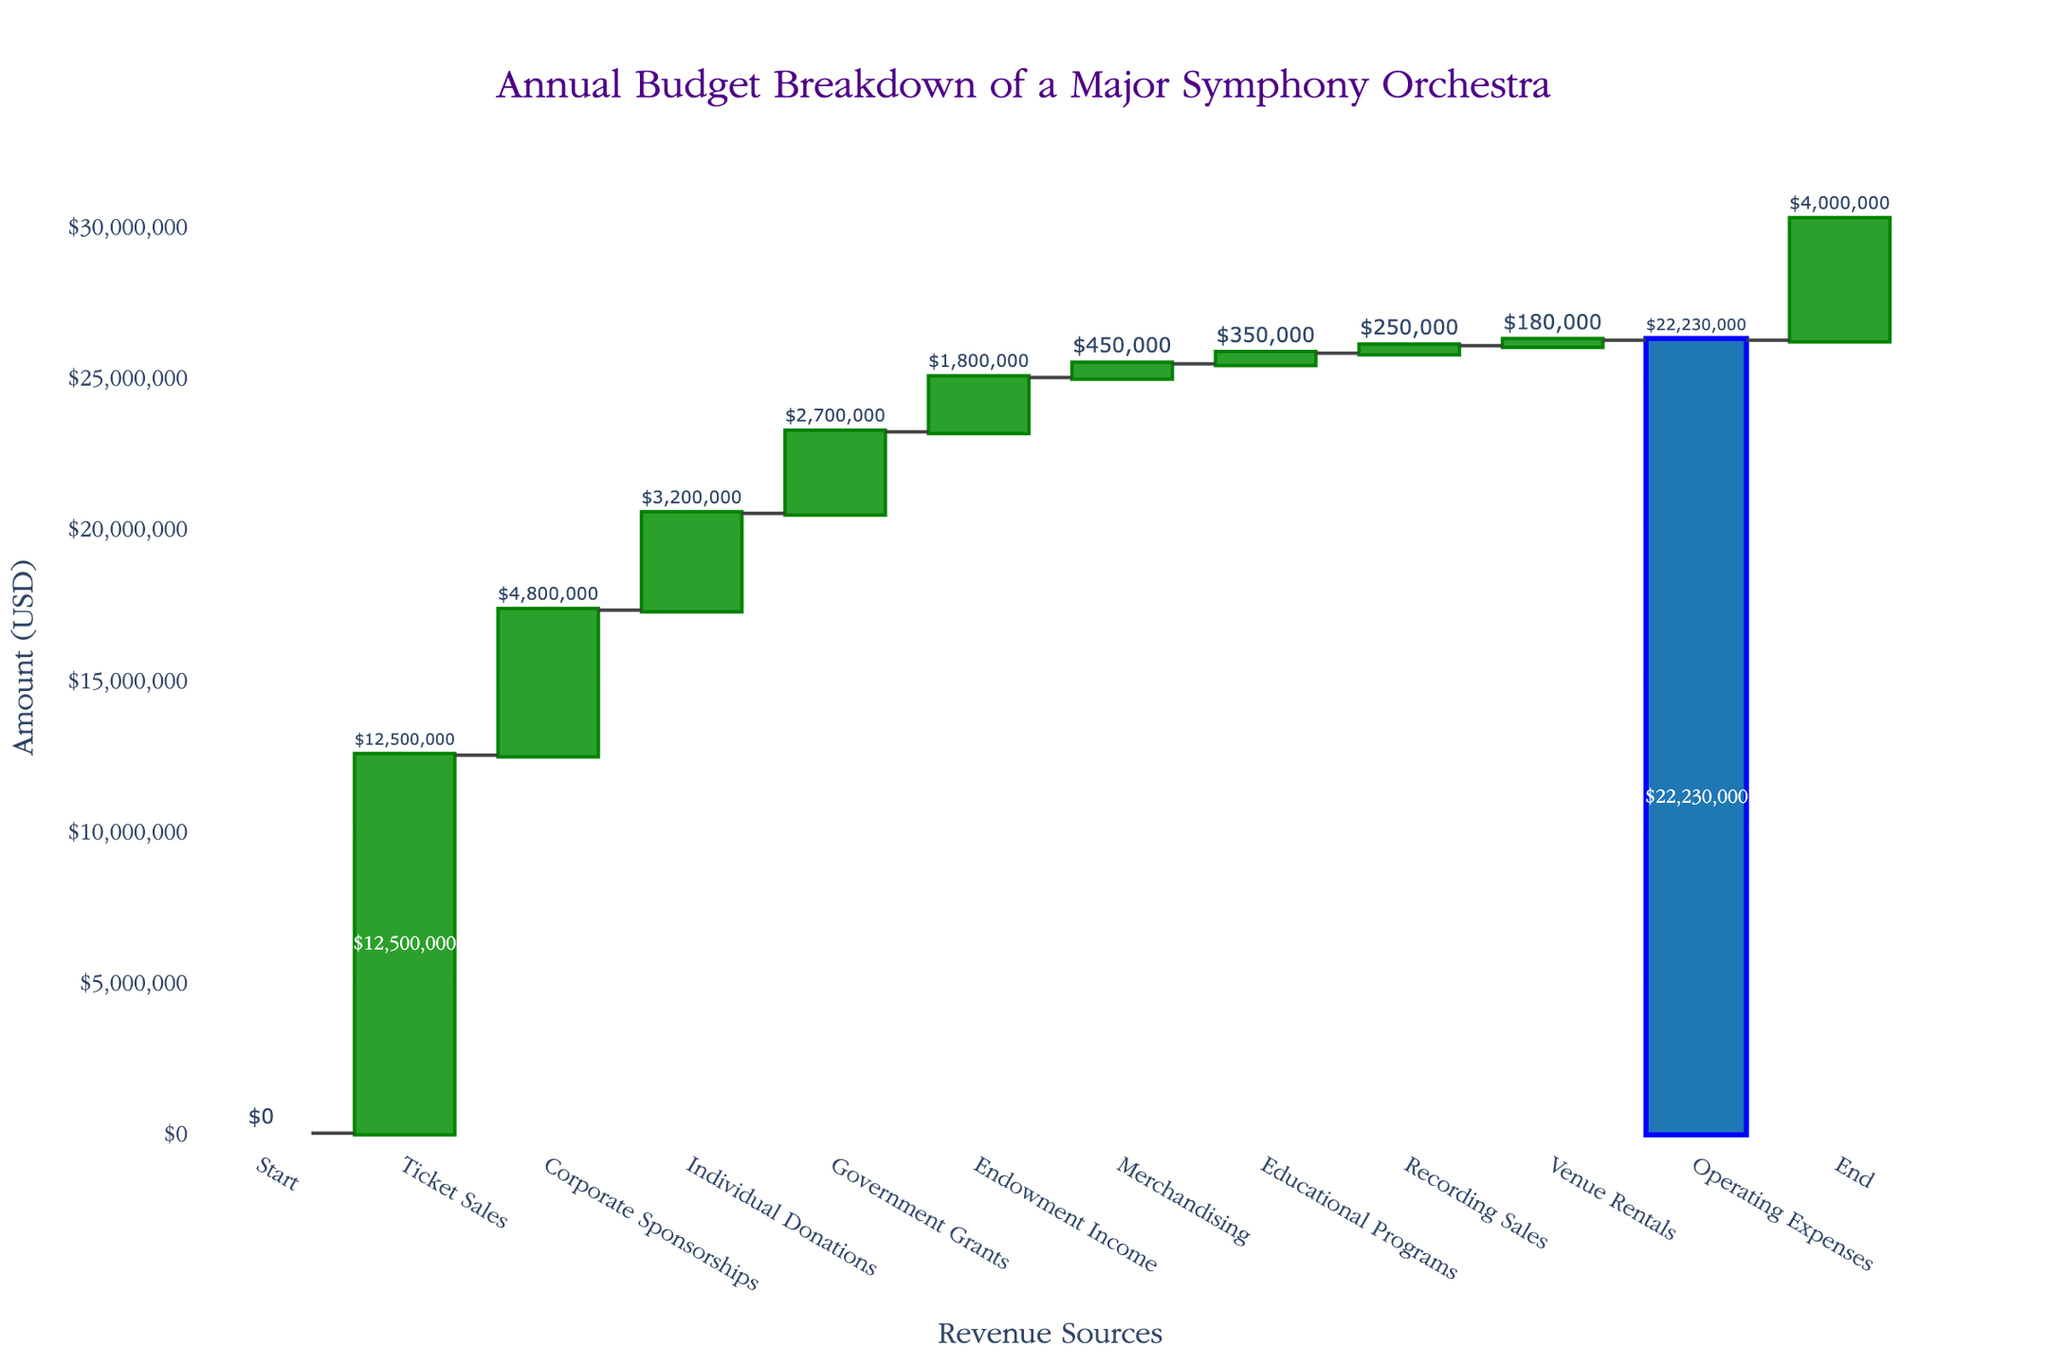what is the title of the chart? The title is displayed prominently at the top of the chart and reads, "Annual Budget Breakdown of a Major Symphony Orchestra".
Answer: Annual Budget Breakdown of a Major Symphony Orchestra How many categories are shown in the waterfall chart? By counting the individual bars on the x-axis of the chart, we can see the categories: Start, Ticket Sales, Corporate Sponsorships, Individual Donations, Government Grants, Endowment Income, Merchandising, Educational Programs, Recording Sales, Venue Rentals, Operating Expenses, and End. This sums up to 12 categories.
Answer: 12 What is the color used to indicate increasing values? The bars that represent increasing values are colored green, which indicates positive contributions to the revenue.
Answer: Green What is the total revenue from "Ticket Sales," "Corporate Sponsorships," and "Individual Donations"? Add the values for Ticket Sales ($12,500,000), Corporate Sponsorships ($4,800,000), and Individual Donations ($3,200,000). $12,500,000 + $4,800,000 + $3,200,000 = $20,500,000.
Answer: $20,500,000 What is the overall surplus or deficit before considering the 'End' category? Sum all the amounts excluding the 'Start' and 'End' categories: $0 + $12,500,000 + $4,800,000 + $3,200,000 + $2,700,000 + $1,800,000 + $450,000 + $350,000 + $250,000 + $180,000 - $22,230,000. This equals -$3,000,000.
Answer: -$3,000,000 Which revenue source contributes the least to the total revenue? By comparing the amounts visually and numerically, "Recording Sales" adds the least amount, which is $250,000.
Answer: Recording Sales How much more revenue does "Ticket Sales" generate compared to "Government Grants"? Subtract the amount for Government Grants ($2,700,000) from Ticket Sales ($12,500,000). $12,500,000 - $2,700,000 = $9,800,000.
Answer: $9,800,000 What is the total amount of revenue generated by all the revenue sources combined (excluding expenses and 'End')? Sum the values of Ticket Sales ($12,500,000), Corporate Sponsorships ($4,800,000), Individual Donations ($3,200,000), Government Grants ($2,700,000), Endowment Income ($1,800,000), Merchandising ($450,000), Educational Programs ($350,000), Recording Sales ($250,000), and Venue Rentals ($180,000). This results in $26,230,000.
Answer: $26,230,000 Explain how the "End" value is derived based on the chart. The "End" value represents the total surplus or deficit after incorporating all revenue sources and expenses. Starting from $0, add all positive values (totaling $26,230,000) and then subtract the operating expenses ($22,230,000). $26,230,000 - $22,230,000 equals $4,000,000 which is shown as "End".
Answer: $4,000,000 How does the sum of "Endowment Income" and "Merchandising" compare to "Operating Expenses"? First, find the sum of Endowment Income and Merchandising: $1,800,000 + $450,000 = $2,250,000. Next, compare this sum to Operating Expenses, which is -$22,230,000. $2,250,000 is significantly less than $22,230,000.
Answer: Less than Operating Expenses 